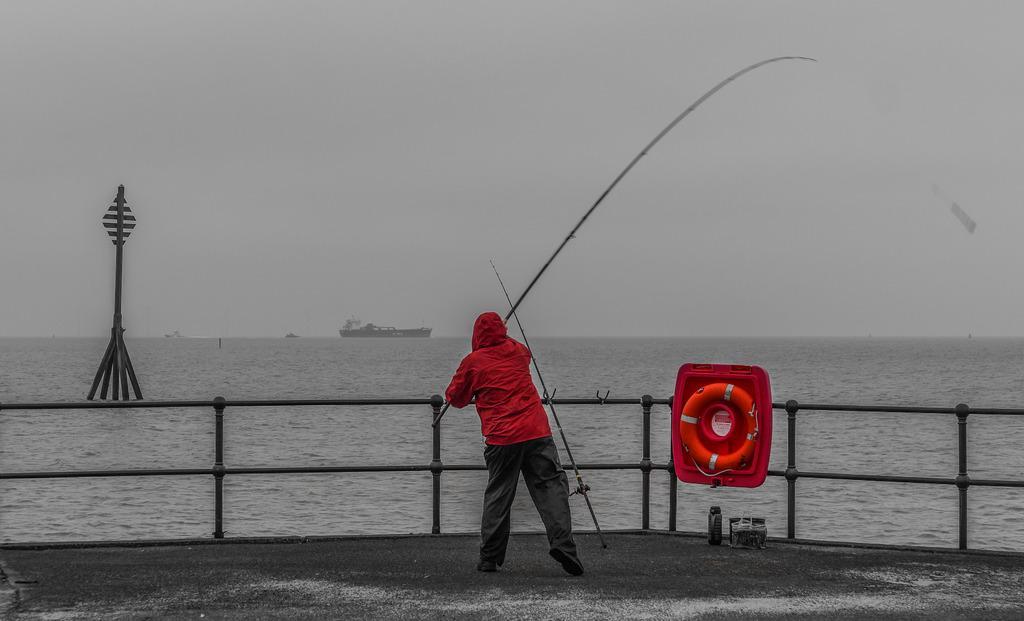Describe this image in one or two sentences. Here a man is standing and fishing he wore a red color coat. This is water and in the long back side a ship is travelling in the sea. 